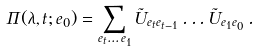<formula> <loc_0><loc_0><loc_500><loc_500>\Pi ( \lambda , t ; e _ { 0 } ) = \sum _ { e _ { t } \dots e _ { 1 } } \tilde { U } _ { e _ { t } e _ { t - 1 } } \dots \tilde { U } _ { e _ { 1 } e _ { 0 } } \, .</formula> 